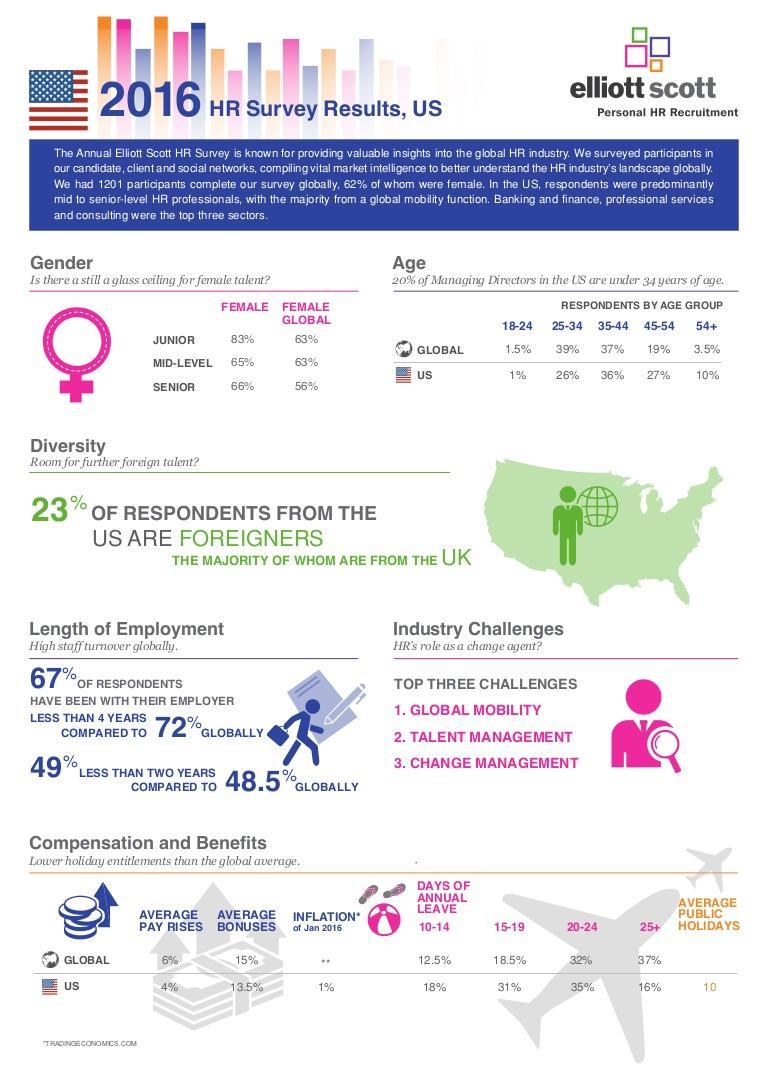Indicate a few pertinent items in this graphic. According to the given data, 48.5% of employees were working for less than two years with their employer globally. According to a 2016 HR survey, the average number of public holidays offered to U.S. employees is 10. Thirty-three percent of respondents in the U.S. have been with their employer for more than 4 years, according to the data. According to the 2016 HR survey, the average bonus in the U.S. was approximately 13.5% of an employee's salary. According to a survey, 56% of female employees globally believed that there is still a glass ceiling for female talents in senior level positions. 